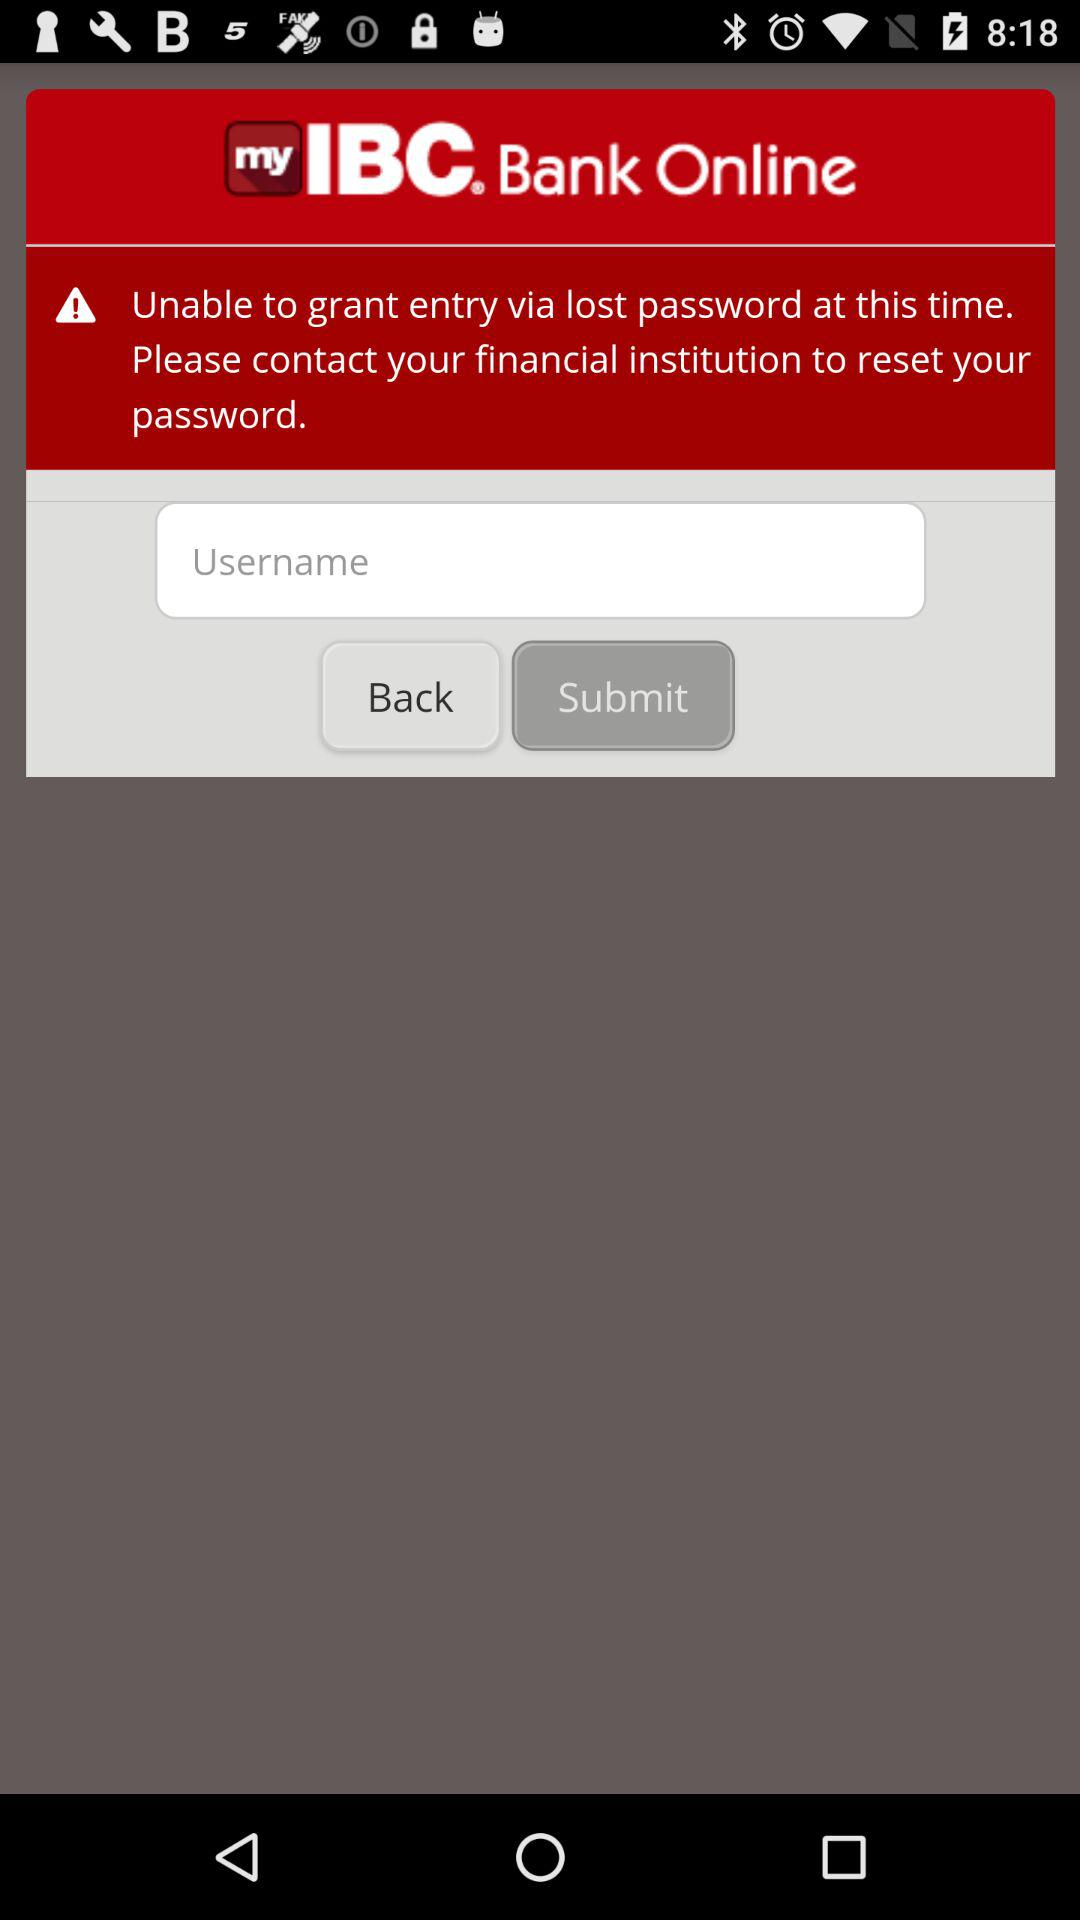What is the application name? The application name is "IBC Bank". 